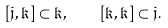Convert formula to latex. <formula><loc_0><loc_0><loc_500><loc_500>[ \mathfrak { j } , \mathfrak { k } ] \subset \mathfrak { k } , \quad [ \mathfrak { k } , \mathfrak { k } ] \subset \mathfrak { j } .</formula> 